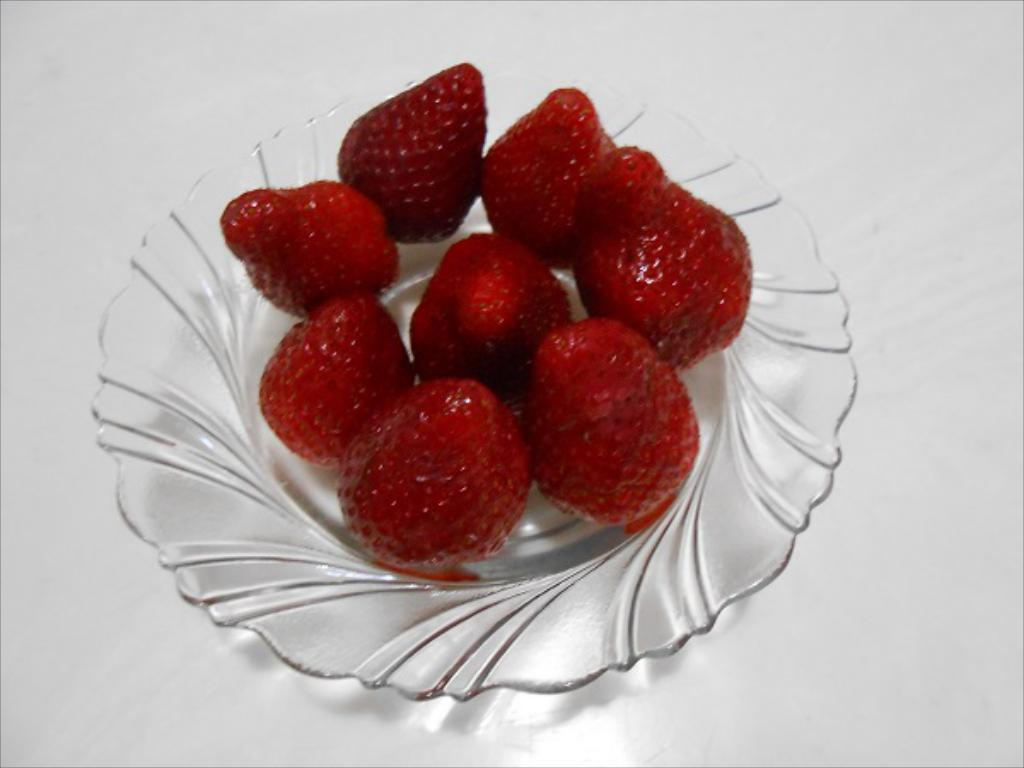What type of container is visible in the image? There is a glass bowl in the image. What is the color of the surface beneath the glass bowl? The glass bowl is on a white surface. What is inside the glass bowl? There are strawberries in the bowl. What is the color of the strawberries? The strawberries are red in color. How does the bear contribute to the operation of the strawberry-filled glass bowl in the image? There is no bear present in the image, and therefore no contribution to the operation of the strawberry-filled glass bowl can be observed. 